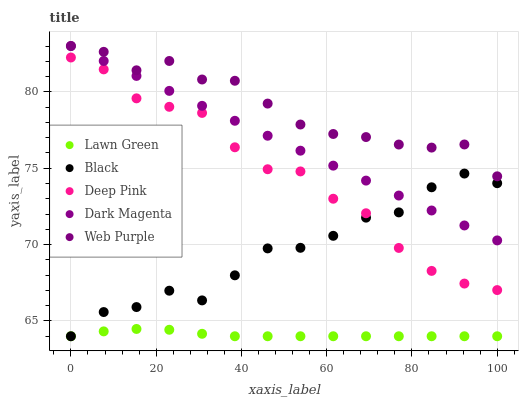Does Lawn Green have the minimum area under the curve?
Answer yes or no. Yes. Does Web Purple have the maximum area under the curve?
Answer yes or no. Yes. Does Deep Pink have the minimum area under the curve?
Answer yes or no. No. Does Deep Pink have the maximum area under the curve?
Answer yes or no. No. Is Dark Magenta the smoothest?
Answer yes or no. Yes. Is Black the roughest?
Answer yes or no. Yes. Is Web Purple the smoothest?
Answer yes or no. No. Is Web Purple the roughest?
Answer yes or no. No. Does Lawn Green have the lowest value?
Answer yes or no. Yes. Does Deep Pink have the lowest value?
Answer yes or no. No. Does Dark Magenta have the highest value?
Answer yes or no. Yes. Does Deep Pink have the highest value?
Answer yes or no. No. Is Lawn Green less than Dark Magenta?
Answer yes or no. Yes. Is Dark Magenta greater than Deep Pink?
Answer yes or no. Yes. Does Black intersect Lawn Green?
Answer yes or no. Yes. Is Black less than Lawn Green?
Answer yes or no. No. Is Black greater than Lawn Green?
Answer yes or no. No. Does Lawn Green intersect Dark Magenta?
Answer yes or no. No. 